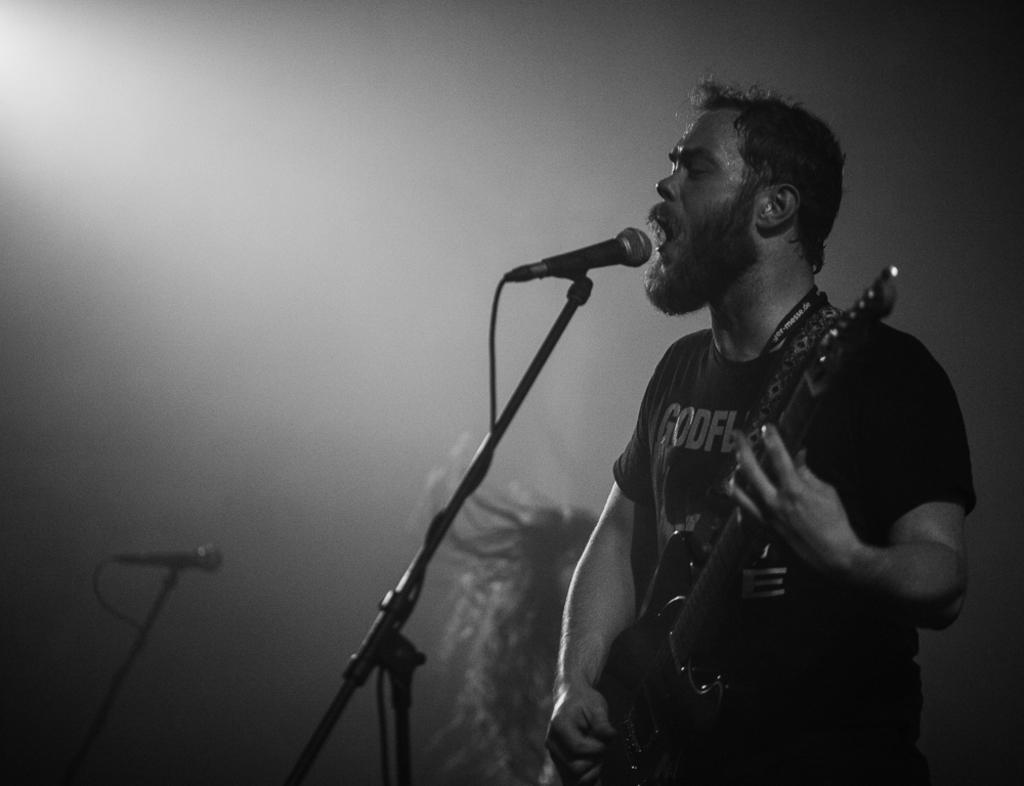What is the man in the image doing? The man is playing a guitar and singing a song. What object is in front of the man? There is a microphone in front of the man. Are there any other people in the image? Yes, there is another person in the image. Where is the second microphone located? The second microphone is in the left bottom corner of the image. What type of cheese is the man using to play the guitar in the image? There is no cheese present in the image, and the man is playing a regular guitar, not a cheese-based instrument. 